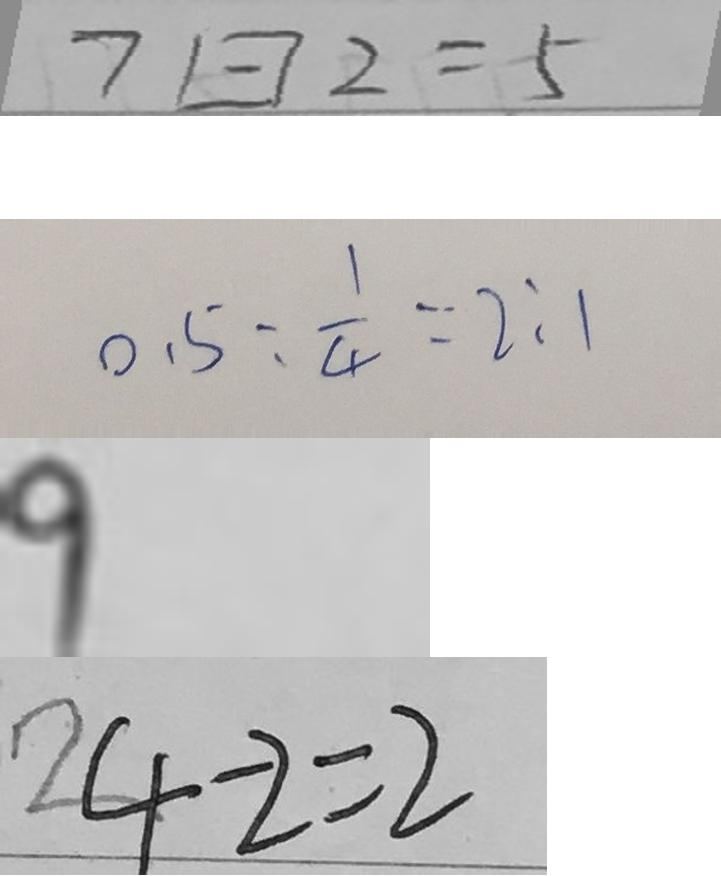<formula> <loc_0><loc_0><loc_500><loc_500>7 \boxed { - } 2 = 5 
 0 . 5 : \frac { 1 } { 4 } = 2 : 1 
 9 
 4 - 2 = 2</formula> 